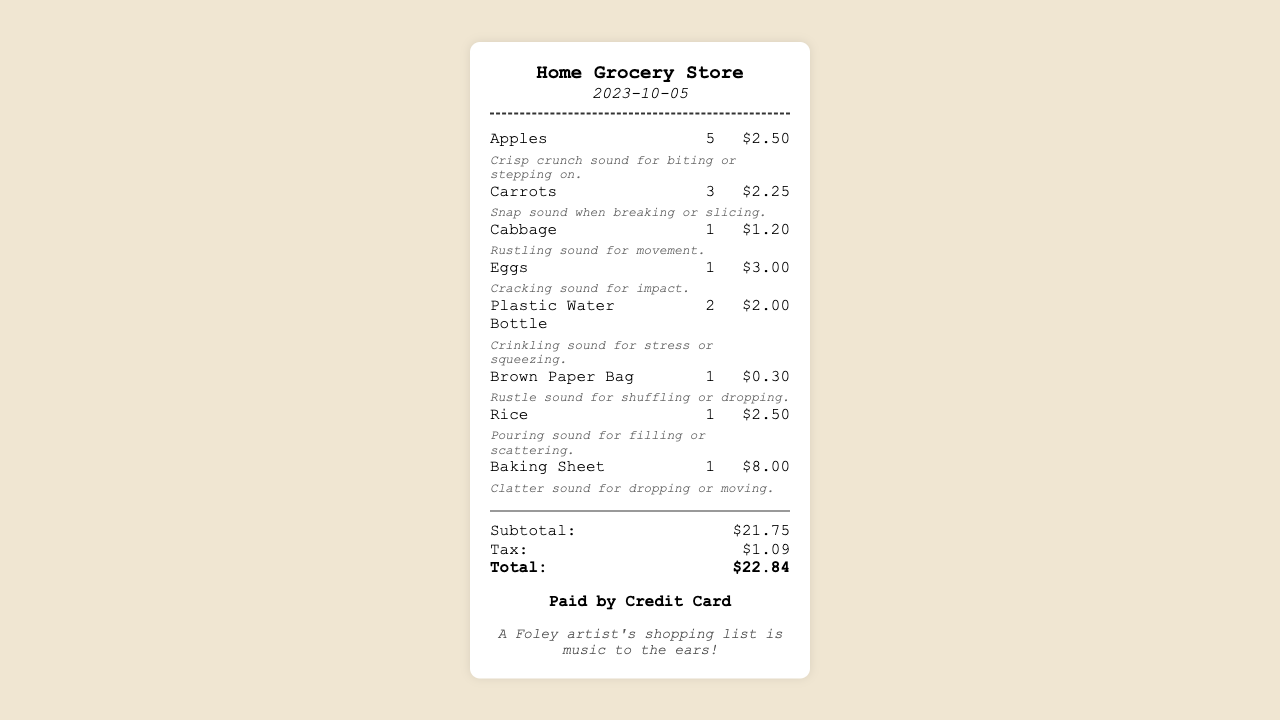What is the store name? The store name is located at the top of the receipt.
Answer: Home Grocery Store What date was the receipt issued? The date is displayed below the store name.
Answer: 2023-10-05 How many apples were purchased? The quantity of apples is shown in the item list.
Answer: 5 What was the price of the baking sheet? The price for the baking sheet is indicated next to the item name.
Answer: $8.00 What is the total amount of tax? The tax amount is listed in the totals section.
Answer: $1.09 What sound effect is associated with carrots? The sound effect is described next to the carrots item.
Answer: Snap sound when breaking or slicing How many plastic water bottles were bought? The quantity of plastic water bottles is stated in the item list.
Answer: 2 What is the subtotal of the groceries? The subtotal is provided in the totals section of the receipt.
Answer: $21.75 What do the two words describe in the foley note? The foley note highlights the purpose of the shopping list for a Foley artist.
Answer: music to the ears 